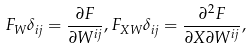Convert formula to latex. <formula><loc_0><loc_0><loc_500><loc_500>F _ { W } \delta _ { i j } = \frac { \partial F } { \partial W ^ { i j } } , F _ { X W } \delta _ { i j } = \frac { \partial ^ { 2 } F } { \partial X \partial W ^ { i j } } , \\</formula> 